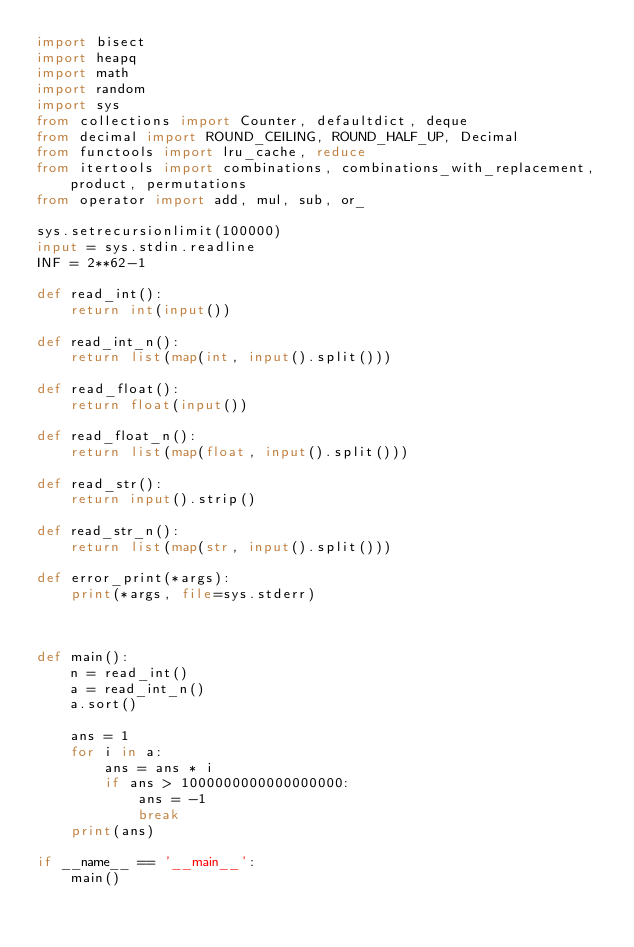Convert code to text. <code><loc_0><loc_0><loc_500><loc_500><_Python_>import bisect
import heapq
import math
import random
import sys
from collections import Counter, defaultdict, deque
from decimal import ROUND_CEILING, ROUND_HALF_UP, Decimal
from functools import lru_cache, reduce
from itertools import combinations, combinations_with_replacement, product, permutations
from operator import add, mul, sub, or_

sys.setrecursionlimit(100000)
input = sys.stdin.readline
INF = 2**62-1

def read_int():
    return int(input())

def read_int_n():
    return list(map(int, input().split()))

def read_float():
    return float(input())

def read_float_n():
    return list(map(float, input().split()))

def read_str():
    return input().strip()

def read_str_n():
    return list(map(str, input().split()))

def error_print(*args):
    print(*args, file=sys.stderr)



def main():
    n = read_int()
    a = read_int_n()
    a.sort()

    ans = 1
    for i in a:
        ans = ans * i
        if ans > 1000000000000000000:
            ans = -1
            break
    print(ans)

if __name__ == '__main__':
    main()</code> 